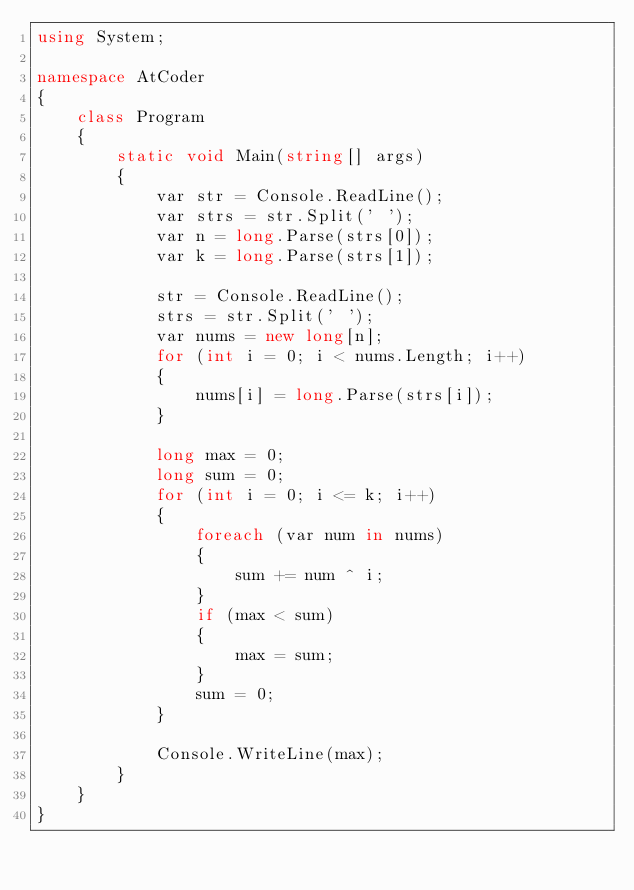Convert code to text. <code><loc_0><loc_0><loc_500><loc_500><_C#_>using System;

namespace AtCoder
{
    class Program
    {
        static void Main(string[] args)
        {
            var str = Console.ReadLine();
            var strs = str.Split(' ');
            var n = long.Parse(strs[0]);
            var k = long.Parse(strs[1]);

            str = Console.ReadLine();
            strs = str.Split(' ');
            var nums = new long[n];
            for (int i = 0; i < nums.Length; i++)
            {
                nums[i] = long.Parse(strs[i]);
            }

            long max = 0;
            long sum = 0;
            for (int i = 0; i <= k; i++)
            {
                foreach (var num in nums)
                {
                    sum += num ^ i;
                }
                if (max < sum)
                {
                    max = sum;
                }
                sum = 0;
            }

            Console.WriteLine(max);
        }
    }
}
</code> 